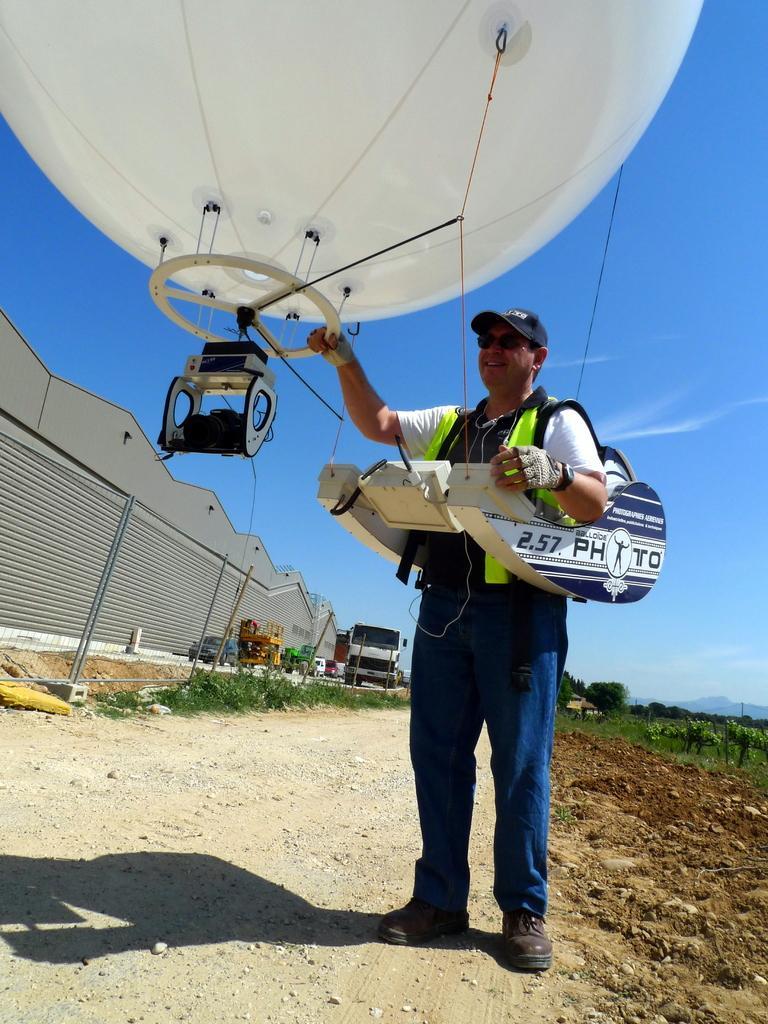Please provide a concise description of this image. This picture is clicked outside. On the right we can see a person wearing some objects and holding an object seems to be a hot air balloon and standing. In the background we can see the sky, trees, plants, green grass, group of vehicles, shutters, metal rods and some other objects. 